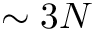Convert formula to latex. <formula><loc_0><loc_0><loc_500><loc_500>\sim 3 N</formula> 